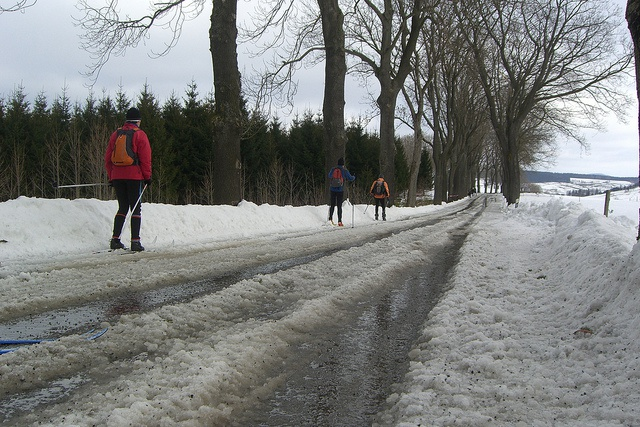Describe the objects in this image and their specific colors. I can see people in lightgray, black, maroon, and brown tones, people in lightgray, black, maroon, navy, and gray tones, backpack in lightgray, black, maroon, and brown tones, people in lightgray, black, gray, maroon, and brown tones, and skis in lightgray, black, gray, and blue tones in this image. 